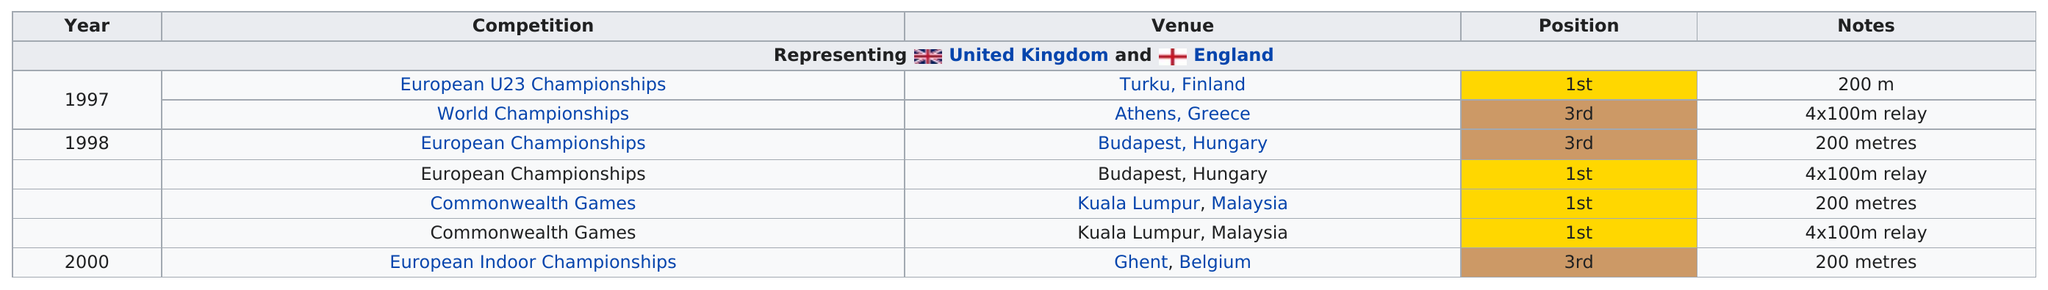Draw attention to some important aspects in this diagram. Besides the European Under-23 Championship, the following competitions have also achieved first-place rankings: the European Championships and the Commonwealth Games. The following competitions have the same relay as the World Championships that were held in Athens, Greece: the European Championships and the Commonwealth Games. There were multiple competitions that took place in Budapest, Hungary, and one of the competitors came in first place. Golding never came in second place more than zero times. A total of three 4x100m relay races were held. 